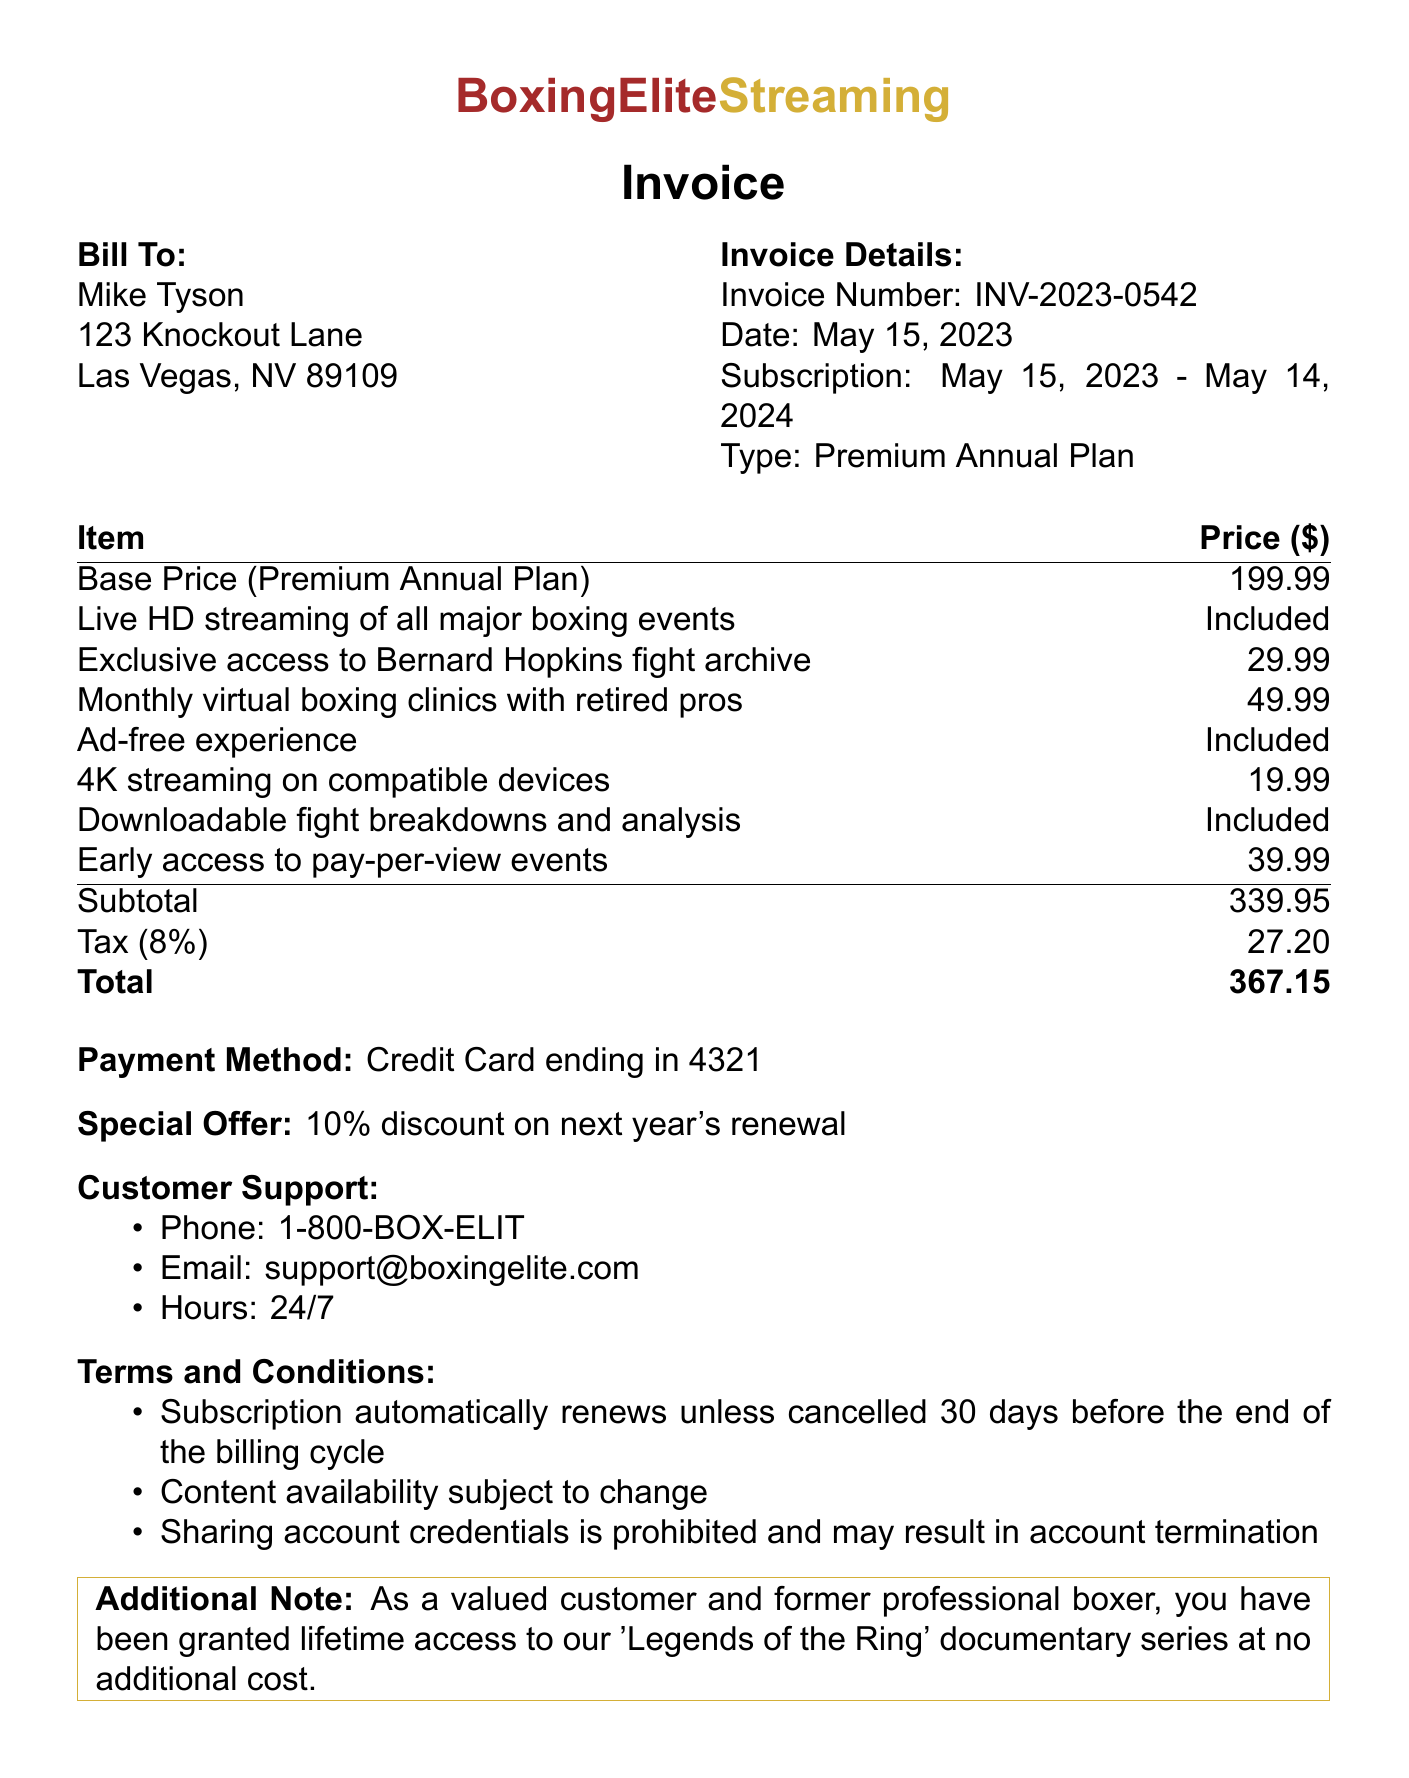What is the invoice number? The invoice number is a specific identifier for the transaction found in the document.
Answer: INV-2023-0542 What is the total amount due? The total amount is the final charge including tax and is presented at the bottom of the invoice.
Answer: 367.15 Who is the customer? The customer name is clearly stated at the beginning of the document.
Answer: Mike Tyson What is the subscription period? The subscription period indicates the duration of the service, specified in the document.
Answer: May 15, 2023 - May 14, 2024 How much is the tax amount? The tax amount is a specific cost associated with the subtotal and is detailed in the calculations.
Answer: 27.20 What features are included in the base price? This question requires understanding of the features that come without additional charges within the subscription.
Answer: Live HD streaming of all major boxing events, Ad-free experience, Downloadable fight breakdowns and analysis What special offer is provided? The special offer is mentioned towards the end of the document as an incentive for renewal.
Answer: 10% discount on next year's renewal What payment method was used? The payment method indicates how the transaction was completed, which is specified in the invoice.
Answer: Credit Card ending in 4321 What are the customer support contact details? The support details include contact methods and availability, outlined in a specific section of the document.
Answer: Phone: 1-800-BOX-ELIT, Email: support@boxingelite.com, Hours: 24/7 